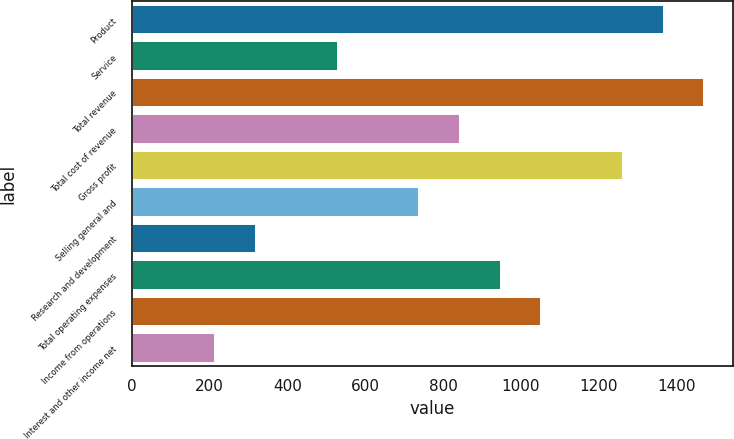<chart> <loc_0><loc_0><loc_500><loc_500><bar_chart><fcel>Product<fcel>Service<fcel>Total revenue<fcel>Total cost of revenue<fcel>Gross profit<fcel>Selling general and<fcel>Research and development<fcel>Total operating expenses<fcel>Income from operations<fcel>Interest and other income net<nl><fcel>1366.12<fcel>529.08<fcel>1470.75<fcel>842.97<fcel>1261.49<fcel>738.34<fcel>319.82<fcel>947.6<fcel>1052.23<fcel>215.19<nl></chart> 